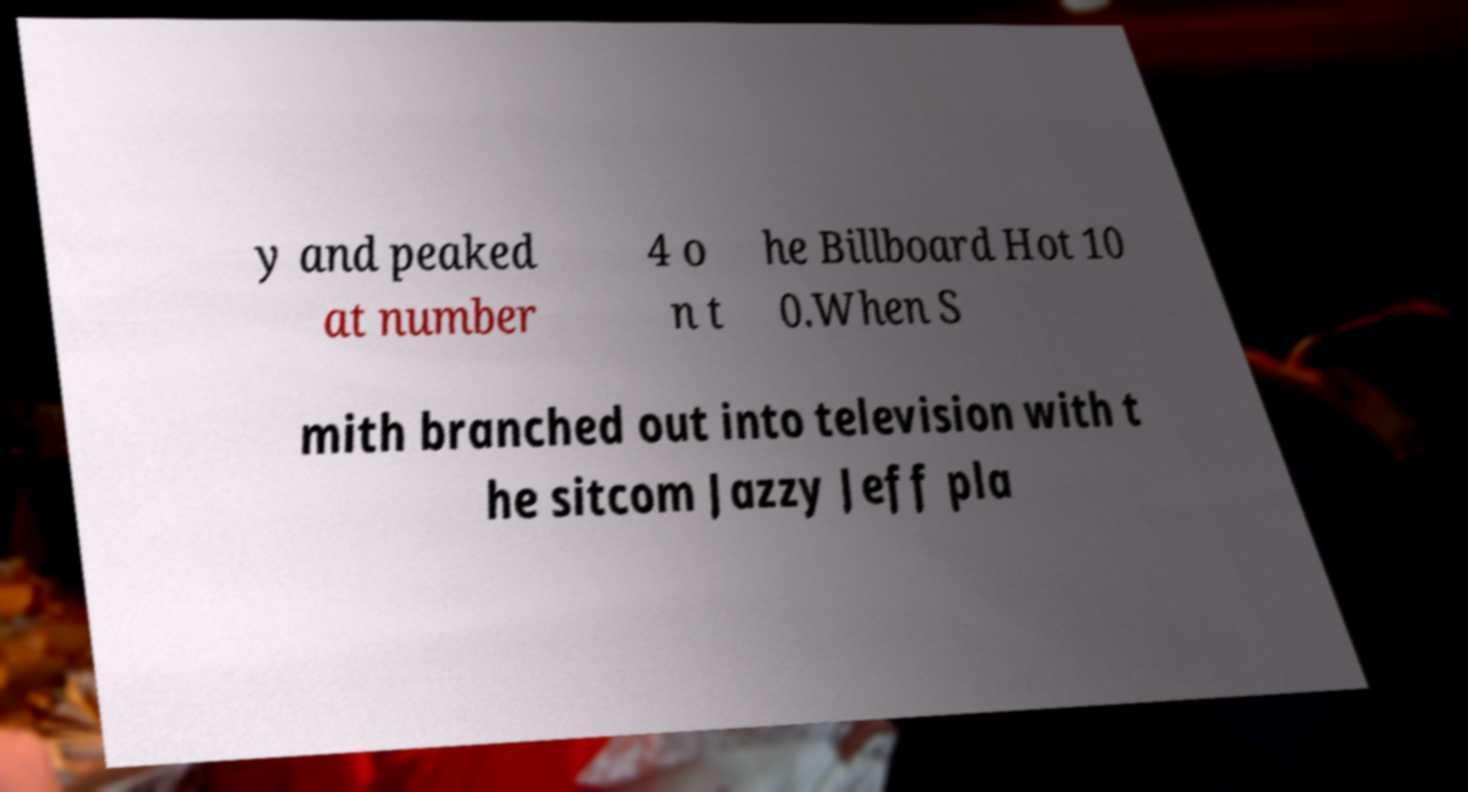Please identify and transcribe the text found in this image. y and peaked at number 4 o n t he Billboard Hot 10 0.When S mith branched out into television with t he sitcom Jazzy Jeff pla 